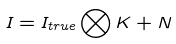Convert formula to latex. <formula><loc_0><loc_0><loc_500><loc_500>I = I _ { t r u e } \bigotimes K + N</formula> 